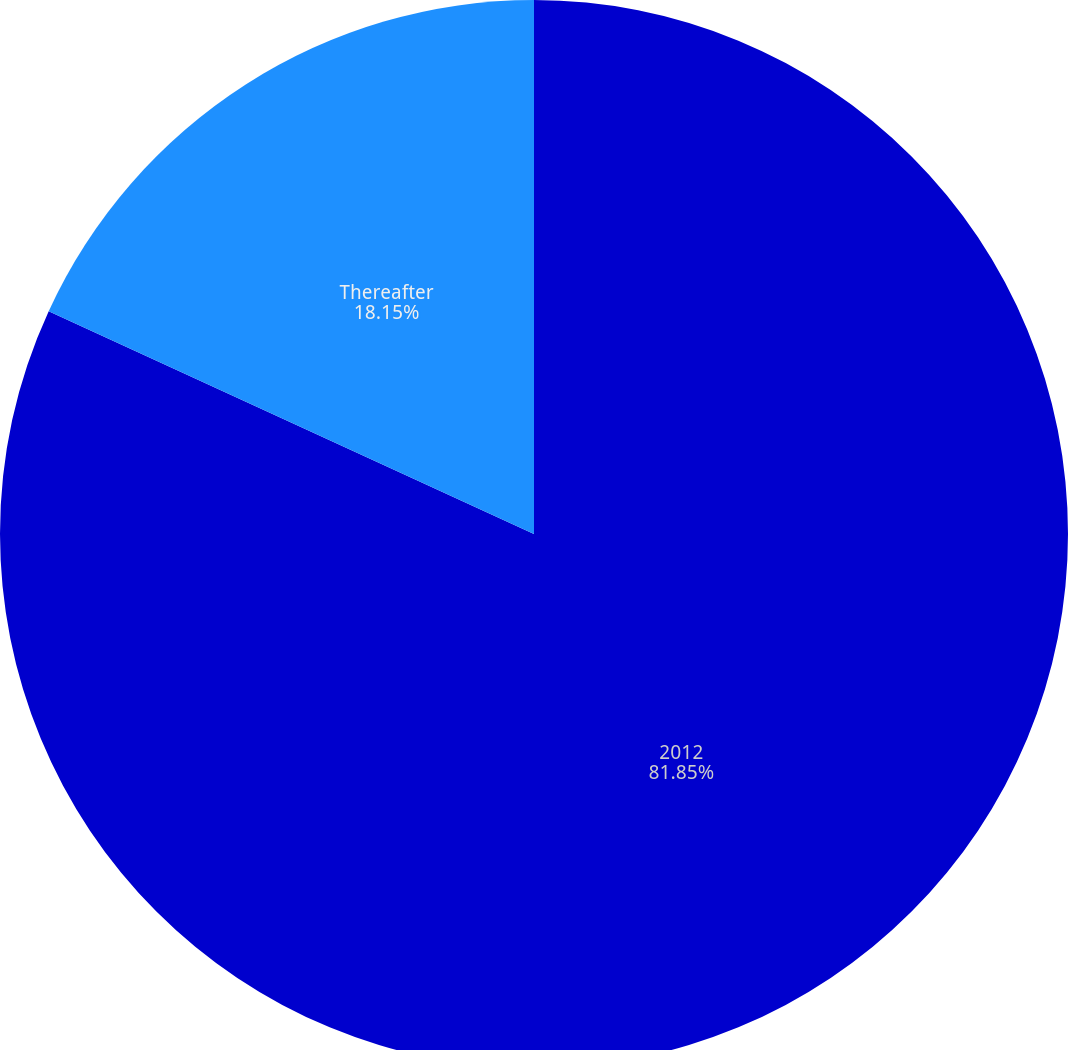<chart> <loc_0><loc_0><loc_500><loc_500><pie_chart><fcel>2012<fcel>Thereafter<nl><fcel>81.85%<fcel>18.15%<nl></chart> 